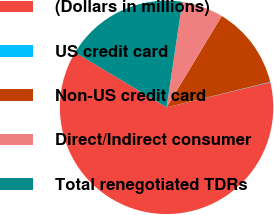Convert chart to OTSL. <chart><loc_0><loc_0><loc_500><loc_500><pie_chart><fcel>(Dollars in millions)<fcel>US credit card<fcel>Non-US credit card<fcel>Direct/Indirect consumer<fcel>Total renegotiated TDRs<nl><fcel>62.37%<fcel>0.06%<fcel>12.52%<fcel>6.29%<fcel>18.75%<nl></chart> 